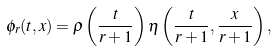Convert formula to latex. <formula><loc_0><loc_0><loc_500><loc_500>\phi _ { r } ( t , x ) = \rho \left ( \frac { t } { r + 1 } \right ) \eta \left ( \frac { t } { r + 1 } , \frac { x } { r + 1 } \right ) ,</formula> 